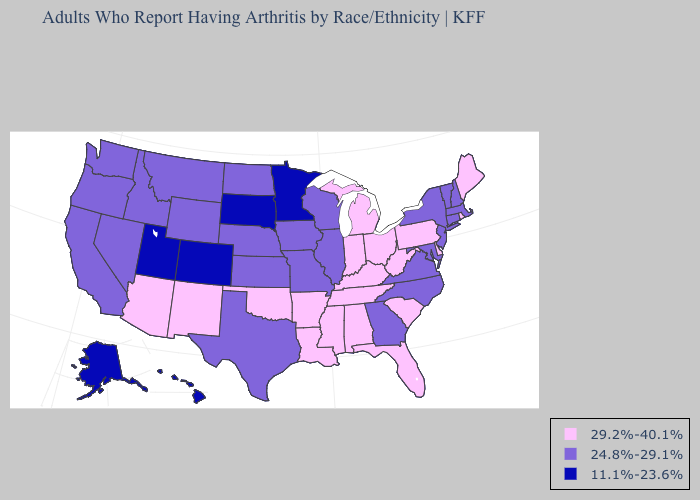Name the states that have a value in the range 29.2%-40.1%?
Quick response, please. Alabama, Arizona, Arkansas, Delaware, Florida, Indiana, Kentucky, Louisiana, Maine, Michigan, Mississippi, New Mexico, Ohio, Oklahoma, Pennsylvania, Rhode Island, South Carolina, Tennessee, West Virginia. Name the states that have a value in the range 11.1%-23.6%?
Quick response, please. Alaska, Colorado, Hawaii, Minnesota, South Dakota, Utah. Name the states that have a value in the range 11.1%-23.6%?
Answer briefly. Alaska, Colorado, Hawaii, Minnesota, South Dakota, Utah. What is the highest value in the Northeast ?
Quick response, please. 29.2%-40.1%. What is the lowest value in states that border Texas?
Keep it brief. 29.2%-40.1%. Name the states that have a value in the range 11.1%-23.6%?
Write a very short answer. Alaska, Colorado, Hawaii, Minnesota, South Dakota, Utah. Name the states that have a value in the range 29.2%-40.1%?
Give a very brief answer. Alabama, Arizona, Arkansas, Delaware, Florida, Indiana, Kentucky, Louisiana, Maine, Michigan, Mississippi, New Mexico, Ohio, Oklahoma, Pennsylvania, Rhode Island, South Carolina, Tennessee, West Virginia. What is the value of Oregon?
Quick response, please. 24.8%-29.1%. Which states have the lowest value in the South?
Answer briefly. Georgia, Maryland, North Carolina, Texas, Virginia. Which states have the lowest value in the MidWest?
Quick response, please. Minnesota, South Dakota. Which states hav the highest value in the MidWest?
Concise answer only. Indiana, Michigan, Ohio. What is the value of Alaska?
Keep it brief. 11.1%-23.6%. What is the lowest value in the USA?
Be succinct. 11.1%-23.6%. Which states have the highest value in the USA?
Answer briefly. Alabama, Arizona, Arkansas, Delaware, Florida, Indiana, Kentucky, Louisiana, Maine, Michigan, Mississippi, New Mexico, Ohio, Oklahoma, Pennsylvania, Rhode Island, South Carolina, Tennessee, West Virginia. What is the value of Vermont?
Answer briefly. 24.8%-29.1%. 